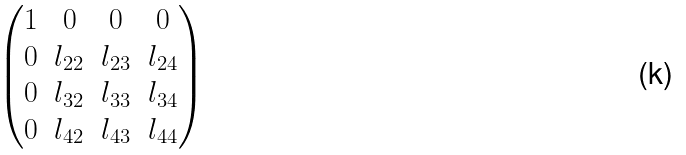<formula> <loc_0><loc_0><loc_500><loc_500>\begin{pmatrix} 1 & 0 & 0 & 0 \\ 0 & l _ { 2 2 } & l _ { 2 3 } & l _ { 2 4 } \\ 0 & l _ { 3 2 } & l _ { 3 3 } & l _ { 3 4 } \\ 0 & l _ { 4 2 } & l _ { 4 3 } & l _ { 4 4 } \end{pmatrix}</formula> 